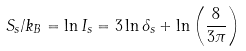<formula> <loc_0><loc_0><loc_500><loc_500>S _ { s } / k _ { B } = \ln I _ { s } = 3 \ln \delta _ { s } + \ln \left ( \frac { 8 } { 3 \pi } \right )</formula> 